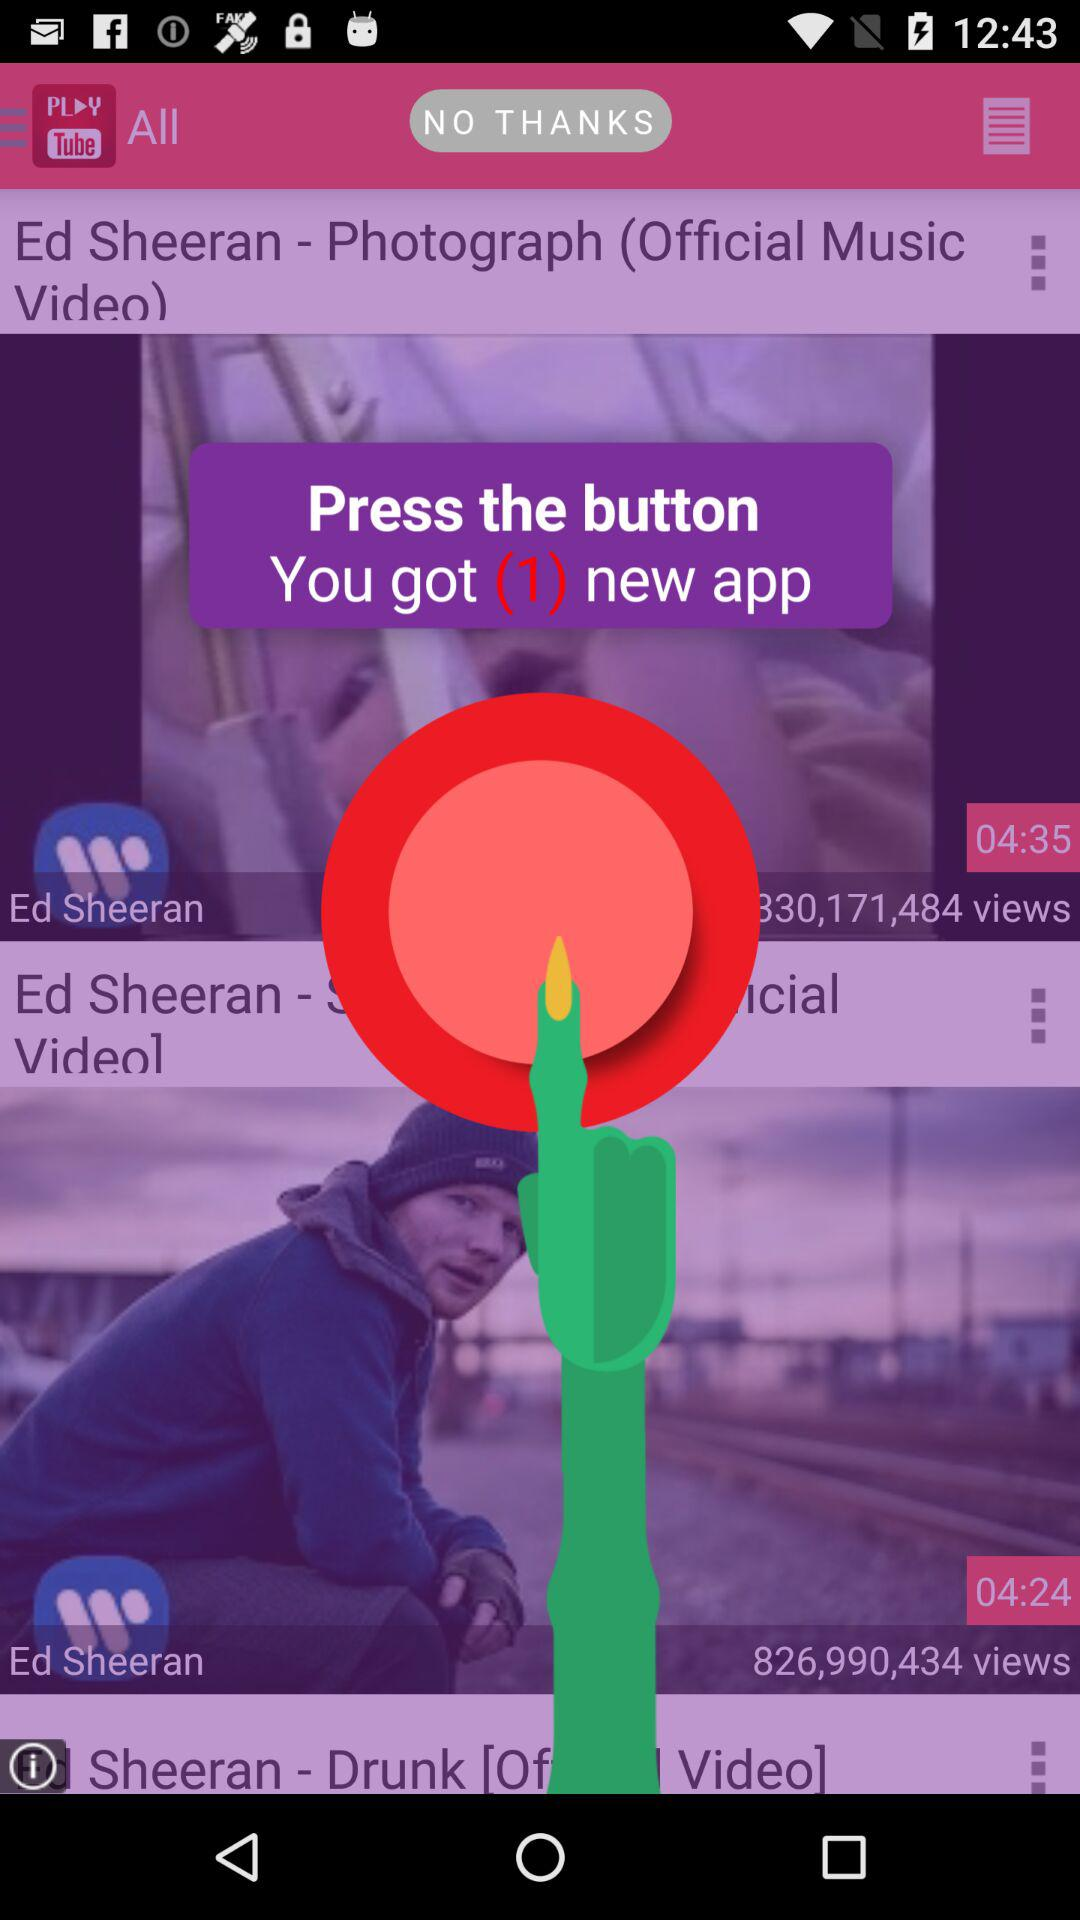Where is Ed Sheeran from?
When the provided information is insufficient, respond with <no answer>. <no answer> 